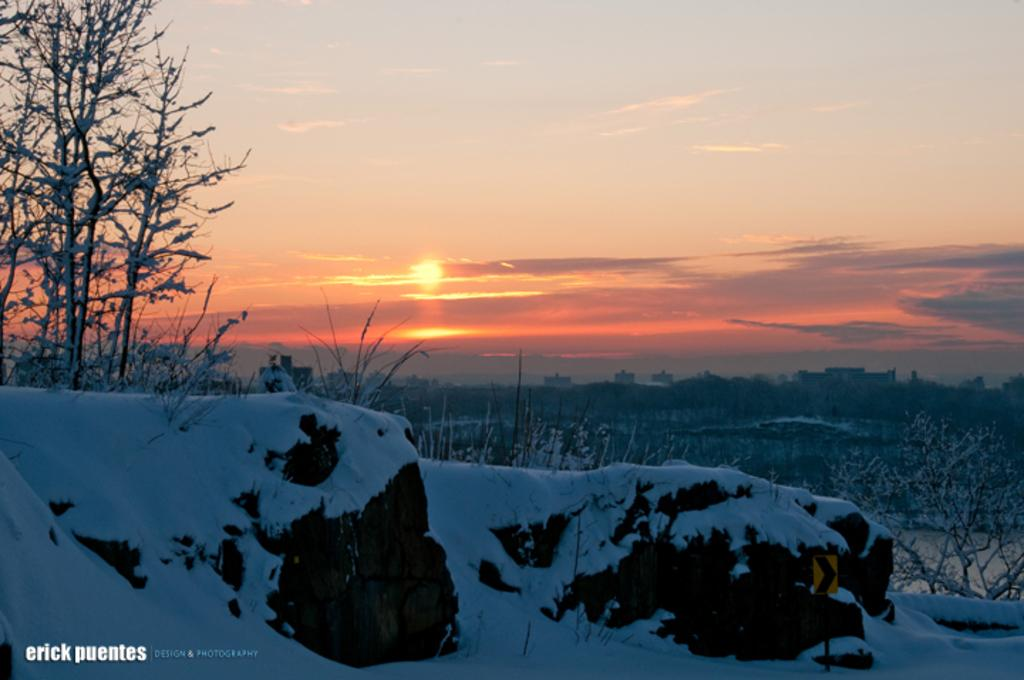What type of weather condition is depicted in the image? There is snow in the image. What type of natural vegetation can be seen in the image? There are trees in the image. What is visible at the top of the image? The sky is visible at the top of the image. What type of farm animals can be seen in the image? There are no farm animals present in the image; it features snow and trees. What type of waste management system is depicted in the image? There is no waste management system present in the image; it features snow, trees, and the sky. 